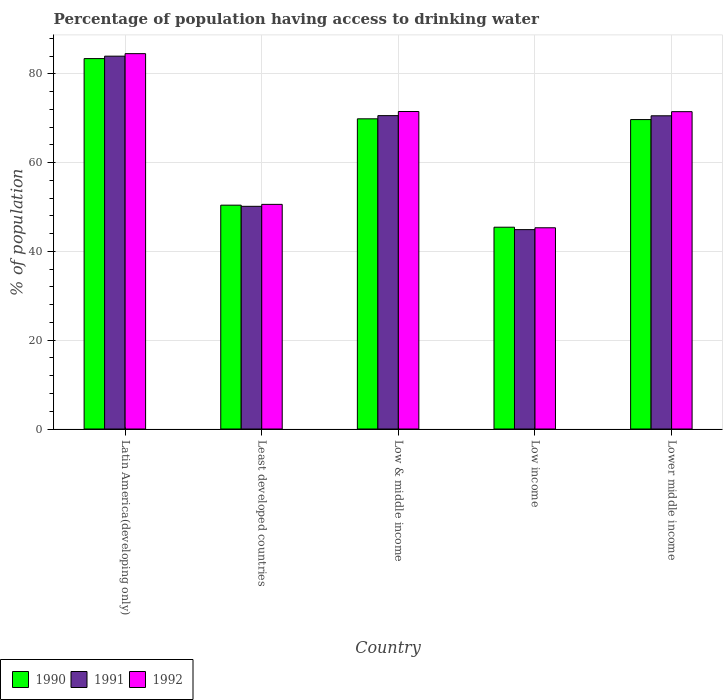Are the number of bars per tick equal to the number of legend labels?
Your response must be concise. Yes. Are the number of bars on each tick of the X-axis equal?
Offer a very short reply. Yes. How many bars are there on the 2nd tick from the right?
Your response must be concise. 3. What is the label of the 2nd group of bars from the left?
Provide a short and direct response. Least developed countries. What is the percentage of population having access to drinking water in 1991 in Latin America(developing only)?
Provide a short and direct response. 83.99. Across all countries, what is the maximum percentage of population having access to drinking water in 1992?
Your answer should be very brief. 84.56. Across all countries, what is the minimum percentage of population having access to drinking water in 1991?
Keep it short and to the point. 44.92. In which country was the percentage of population having access to drinking water in 1992 maximum?
Your answer should be very brief. Latin America(developing only). In which country was the percentage of population having access to drinking water in 1991 minimum?
Provide a short and direct response. Low income. What is the total percentage of population having access to drinking water in 1992 in the graph?
Provide a short and direct response. 323.52. What is the difference between the percentage of population having access to drinking water in 1992 in Latin America(developing only) and that in Low & middle income?
Make the answer very short. 13.04. What is the difference between the percentage of population having access to drinking water in 1991 in Low income and the percentage of population having access to drinking water in 1992 in Low & middle income?
Your response must be concise. -26.61. What is the average percentage of population having access to drinking water in 1991 per country?
Offer a very short reply. 64.05. What is the difference between the percentage of population having access to drinking water of/in 1990 and percentage of population having access to drinking water of/in 1991 in Low income?
Offer a very short reply. 0.54. In how many countries, is the percentage of population having access to drinking water in 1991 greater than 16 %?
Make the answer very short. 5. What is the ratio of the percentage of population having access to drinking water in 1991 in Least developed countries to that in Lower middle income?
Your answer should be very brief. 0.71. What is the difference between the highest and the second highest percentage of population having access to drinking water in 1990?
Offer a terse response. 13.74. What is the difference between the highest and the lowest percentage of population having access to drinking water in 1991?
Provide a short and direct response. 39.08. What does the 3rd bar from the left in Latin America(developing only) represents?
Offer a terse response. 1992. How many bars are there?
Your response must be concise. 15. Are all the bars in the graph horizontal?
Offer a very short reply. No. How many countries are there in the graph?
Make the answer very short. 5. Does the graph contain any zero values?
Provide a short and direct response. No. How many legend labels are there?
Your answer should be compact. 3. How are the legend labels stacked?
Your answer should be very brief. Horizontal. What is the title of the graph?
Provide a short and direct response. Percentage of population having access to drinking water. What is the label or title of the X-axis?
Provide a short and direct response. Country. What is the label or title of the Y-axis?
Your answer should be very brief. % of population. What is the % of population in 1990 in Latin America(developing only)?
Provide a succinct answer. 83.45. What is the % of population in 1991 in Latin America(developing only)?
Offer a very short reply. 83.99. What is the % of population in 1992 in Latin America(developing only)?
Keep it short and to the point. 84.56. What is the % of population in 1990 in Least developed countries?
Your answer should be very brief. 50.43. What is the % of population of 1991 in Least developed countries?
Ensure brevity in your answer.  50.17. What is the % of population of 1992 in Least developed countries?
Ensure brevity in your answer.  50.61. What is the % of population of 1990 in Low & middle income?
Offer a very short reply. 69.88. What is the % of population in 1991 in Low & middle income?
Your answer should be compact. 70.6. What is the % of population in 1992 in Low & middle income?
Keep it short and to the point. 71.53. What is the % of population of 1990 in Low income?
Provide a succinct answer. 45.46. What is the % of population of 1991 in Low income?
Your answer should be compact. 44.92. What is the % of population in 1992 in Low income?
Provide a succinct answer. 45.33. What is the % of population of 1990 in Lower middle income?
Your response must be concise. 69.71. What is the % of population of 1991 in Lower middle income?
Keep it short and to the point. 70.56. What is the % of population in 1992 in Lower middle income?
Make the answer very short. 71.49. Across all countries, what is the maximum % of population in 1990?
Your answer should be very brief. 83.45. Across all countries, what is the maximum % of population of 1991?
Make the answer very short. 83.99. Across all countries, what is the maximum % of population in 1992?
Ensure brevity in your answer.  84.56. Across all countries, what is the minimum % of population of 1990?
Provide a succinct answer. 45.46. Across all countries, what is the minimum % of population in 1991?
Provide a succinct answer. 44.92. Across all countries, what is the minimum % of population of 1992?
Provide a short and direct response. 45.33. What is the total % of population of 1990 in the graph?
Make the answer very short. 318.92. What is the total % of population of 1991 in the graph?
Ensure brevity in your answer.  320.24. What is the total % of population of 1992 in the graph?
Your response must be concise. 323.52. What is the difference between the % of population of 1990 in Latin America(developing only) and that in Least developed countries?
Your response must be concise. 33.02. What is the difference between the % of population of 1991 in Latin America(developing only) and that in Least developed countries?
Provide a short and direct response. 33.83. What is the difference between the % of population of 1992 in Latin America(developing only) and that in Least developed countries?
Your answer should be compact. 33.95. What is the difference between the % of population of 1990 in Latin America(developing only) and that in Low & middle income?
Make the answer very short. 13.57. What is the difference between the % of population in 1991 in Latin America(developing only) and that in Low & middle income?
Your answer should be compact. 13.4. What is the difference between the % of population of 1992 in Latin America(developing only) and that in Low & middle income?
Your answer should be compact. 13.04. What is the difference between the % of population of 1990 in Latin America(developing only) and that in Low income?
Your response must be concise. 37.98. What is the difference between the % of population in 1991 in Latin America(developing only) and that in Low income?
Give a very brief answer. 39.08. What is the difference between the % of population of 1992 in Latin America(developing only) and that in Low income?
Offer a terse response. 39.23. What is the difference between the % of population in 1990 in Latin America(developing only) and that in Lower middle income?
Your response must be concise. 13.74. What is the difference between the % of population in 1991 in Latin America(developing only) and that in Lower middle income?
Your answer should be very brief. 13.43. What is the difference between the % of population of 1992 in Latin America(developing only) and that in Lower middle income?
Offer a very short reply. 13.07. What is the difference between the % of population of 1990 in Least developed countries and that in Low & middle income?
Ensure brevity in your answer.  -19.45. What is the difference between the % of population of 1991 in Least developed countries and that in Low & middle income?
Keep it short and to the point. -20.43. What is the difference between the % of population of 1992 in Least developed countries and that in Low & middle income?
Keep it short and to the point. -20.92. What is the difference between the % of population of 1990 in Least developed countries and that in Low income?
Provide a succinct answer. 4.97. What is the difference between the % of population in 1991 in Least developed countries and that in Low income?
Your answer should be compact. 5.25. What is the difference between the % of population of 1992 in Least developed countries and that in Low income?
Keep it short and to the point. 5.27. What is the difference between the % of population of 1990 in Least developed countries and that in Lower middle income?
Offer a very short reply. -19.28. What is the difference between the % of population of 1991 in Least developed countries and that in Lower middle income?
Provide a succinct answer. -20.39. What is the difference between the % of population of 1992 in Least developed countries and that in Lower middle income?
Your answer should be very brief. -20.88. What is the difference between the % of population of 1990 in Low & middle income and that in Low income?
Ensure brevity in your answer.  24.42. What is the difference between the % of population in 1991 in Low & middle income and that in Low income?
Provide a succinct answer. 25.68. What is the difference between the % of population in 1992 in Low & middle income and that in Low income?
Offer a very short reply. 26.19. What is the difference between the % of population in 1990 in Low & middle income and that in Lower middle income?
Provide a succinct answer. 0.17. What is the difference between the % of population of 1991 in Low & middle income and that in Lower middle income?
Ensure brevity in your answer.  0.03. What is the difference between the % of population of 1992 in Low & middle income and that in Lower middle income?
Offer a terse response. 0.03. What is the difference between the % of population of 1990 in Low income and that in Lower middle income?
Your answer should be very brief. -24.25. What is the difference between the % of population in 1991 in Low income and that in Lower middle income?
Offer a terse response. -25.64. What is the difference between the % of population of 1992 in Low income and that in Lower middle income?
Offer a very short reply. -26.16. What is the difference between the % of population of 1990 in Latin America(developing only) and the % of population of 1991 in Least developed countries?
Give a very brief answer. 33.28. What is the difference between the % of population in 1990 in Latin America(developing only) and the % of population in 1992 in Least developed countries?
Keep it short and to the point. 32.84. What is the difference between the % of population in 1991 in Latin America(developing only) and the % of population in 1992 in Least developed countries?
Your answer should be compact. 33.39. What is the difference between the % of population of 1990 in Latin America(developing only) and the % of population of 1991 in Low & middle income?
Ensure brevity in your answer.  12.85. What is the difference between the % of population of 1990 in Latin America(developing only) and the % of population of 1992 in Low & middle income?
Keep it short and to the point. 11.92. What is the difference between the % of population of 1991 in Latin America(developing only) and the % of population of 1992 in Low & middle income?
Provide a succinct answer. 12.47. What is the difference between the % of population in 1990 in Latin America(developing only) and the % of population in 1991 in Low income?
Keep it short and to the point. 38.53. What is the difference between the % of population of 1990 in Latin America(developing only) and the % of population of 1992 in Low income?
Keep it short and to the point. 38.11. What is the difference between the % of population in 1991 in Latin America(developing only) and the % of population in 1992 in Low income?
Your answer should be compact. 38.66. What is the difference between the % of population in 1990 in Latin America(developing only) and the % of population in 1991 in Lower middle income?
Provide a succinct answer. 12.88. What is the difference between the % of population of 1990 in Latin America(developing only) and the % of population of 1992 in Lower middle income?
Provide a short and direct response. 11.95. What is the difference between the % of population of 1991 in Latin America(developing only) and the % of population of 1992 in Lower middle income?
Provide a succinct answer. 12.5. What is the difference between the % of population of 1990 in Least developed countries and the % of population of 1991 in Low & middle income?
Offer a terse response. -20.17. What is the difference between the % of population of 1990 in Least developed countries and the % of population of 1992 in Low & middle income?
Your answer should be compact. -21.1. What is the difference between the % of population in 1991 in Least developed countries and the % of population in 1992 in Low & middle income?
Provide a succinct answer. -21.36. What is the difference between the % of population of 1990 in Least developed countries and the % of population of 1991 in Low income?
Provide a short and direct response. 5.51. What is the difference between the % of population of 1990 in Least developed countries and the % of population of 1992 in Low income?
Provide a succinct answer. 5.09. What is the difference between the % of population in 1991 in Least developed countries and the % of population in 1992 in Low income?
Your answer should be compact. 4.83. What is the difference between the % of population of 1990 in Least developed countries and the % of population of 1991 in Lower middle income?
Make the answer very short. -20.13. What is the difference between the % of population in 1990 in Least developed countries and the % of population in 1992 in Lower middle income?
Provide a short and direct response. -21.06. What is the difference between the % of population of 1991 in Least developed countries and the % of population of 1992 in Lower middle income?
Your answer should be compact. -21.32. What is the difference between the % of population of 1990 in Low & middle income and the % of population of 1991 in Low income?
Make the answer very short. 24.96. What is the difference between the % of population in 1990 in Low & middle income and the % of population in 1992 in Low income?
Offer a terse response. 24.54. What is the difference between the % of population in 1991 in Low & middle income and the % of population in 1992 in Low income?
Offer a very short reply. 25.26. What is the difference between the % of population in 1990 in Low & middle income and the % of population in 1991 in Lower middle income?
Offer a terse response. -0.69. What is the difference between the % of population of 1990 in Low & middle income and the % of population of 1992 in Lower middle income?
Give a very brief answer. -1.61. What is the difference between the % of population in 1991 in Low & middle income and the % of population in 1992 in Lower middle income?
Your answer should be very brief. -0.9. What is the difference between the % of population in 1990 in Low income and the % of population in 1991 in Lower middle income?
Provide a short and direct response. -25.1. What is the difference between the % of population in 1990 in Low income and the % of population in 1992 in Lower middle income?
Ensure brevity in your answer.  -26.03. What is the difference between the % of population in 1991 in Low income and the % of population in 1992 in Lower middle income?
Provide a short and direct response. -26.57. What is the average % of population of 1990 per country?
Ensure brevity in your answer.  63.78. What is the average % of population in 1991 per country?
Provide a short and direct response. 64.05. What is the average % of population of 1992 per country?
Your answer should be very brief. 64.7. What is the difference between the % of population in 1990 and % of population in 1991 in Latin America(developing only)?
Your answer should be very brief. -0.55. What is the difference between the % of population of 1990 and % of population of 1992 in Latin America(developing only)?
Keep it short and to the point. -1.12. What is the difference between the % of population in 1991 and % of population in 1992 in Latin America(developing only)?
Your response must be concise. -0.57. What is the difference between the % of population in 1990 and % of population in 1991 in Least developed countries?
Offer a very short reply. 0.26. What is the difference between the % of population in 1990 and % of population in 1992 in Least developed countries?
Provide a short and direct response. -0.18. What is the difference between the % of population of 1991 and % of population of 1992 in Least developed countries?
Your answer should be very brief. -0.44. What is the difference between the % of population in 1990 and % of population in 1991 in Low & middle income?
Provide a succinct answer. -0.72. What is the difference between the % of population in 1990 and % of population in 1992 in Low & middle income?
Offer a very short reply. -1.65. What is the difference between the % of population in 1991 and % of population in 1992 in Low & middle income?
Provide a short and direct response. -0.93. What is the difference between the % of population of 1990 and % of population of 1991 in Low income?
Give a very brief answer. 0.54. What is the difference between the % of population in 1990 and % of population in 1992 in Low income?
Offer a very short reply. 0.13. What is the difference between the % of population in 1991 and % of population in 1992 in Low income?
Make the answer very short. -0.42. What is the difference between the % of population of 1990 and % of population of 1991 in Lower middle income?
Your answer should be compact. -0.85. What is the difference between the % of population of 1990 and % of population of 1992 in Lower middle income?
Give a very brief answer. -1.78. What is the difference between the % of population in 1991 and % of population in 1992 in Lower middle income?
Ensure brevity in your answer.  -0.93. What is the ratio of the % of population in 1990 in Latin America(developing only) to that in Least developed countries?
Offer a very short reply. 1.65. What is the ratio of the % of population in 1991 in Latin America(developing only) to that in Least developed countries?
Ensure brevity in your answer.  1.67. What is the ratio of the % of population of 1992 in Latin America(developing only) to that in Least developed countries?
Provide a short and direct response. 1.67. What is the ratio of the % of population in 1990 in Latin America(developing only) to that in Low & middle income?
Give a very brief answer. 1.19. What is the ratio of the % of population in 1991 in Latin America(developing only) to that in Low & middle income?
Keep it short and to the point. 1.19. What is the ratio of the % of population of 1992 in Latin America(developing only) to that in Low & middle income?
Offer a very short reply. 1.18. What is the ratio of the % of population of 1990 in Latin America(developing only) to that in Low income?
Your answer should be very brief. 1.84. What is the ratio of the % of population in 1991 in Latin America(developing only) to that in Low income?
Offer a very short reply. 1.87. What is the ratio of the % of population in 1992 in Latin America(developing only) to that in Low income?
Ensure brevity in your answer.  1.87. What is the ratio of the % of population of 1990 in Latin America(developing only) to that in Lower middle income?
Provide a short and direct response. 1.2. What is the ratio of the % of population of 1991 in Latin America(developing only) to that in Lower middle income?
Offer a very short reply. 1.19. What is the ratio of the % of population of 1992 in Latin America(developing only) to that in Lower middle income?
Your response must be concise. 1.18. What is the ratio of the % of population of 1990 in Least developed countries to that in Low & middle income?
Provide a succinct answer. 0.72. What is the ratio of the % of population in 1991 in Least developed countries to that in Low & middle income?
Ensure brevity in your answer.  0.71. What is the ratio of the % of population in 1992 in Least developed countries to that in Low & middle income?
Your response must be concise. 0.71. What is the ratio of the % of population of 1990 in Least developed countries to that in Low income?
Your response must be concise. 1.11. What is the ratio of the % of population in 1991 in Least developed countries to that in Low income?
Offer a very short reply. 1.12. What is the ratio of the % of population of 1992 in Least developed countries to that in Low income?
Ensure brevity in your answer.  1.12. What is the ratio of the % of population in 1990 in Least developed countries to that in Lower middle income?
Provide a short and direct response. 0.72. What is the ratio of the % of population in 1991 in Least developed countries to that in Lower middle income?
Make the answer very short. 0.71. What is the ratio of the % of population of 1992 in Least developed countries to that in Lower middle income?
Keep it short and to the point. 0.71. What is the ratio of the % of population in 1990 in Low & middle income to that in Low income?
Offer a very short reply. 1.54. What is the ratio of the % of population of 1991 in Low & middle income to that in Low income?
Ensure brevity in your answer.  1.57. What is the ratio of the % of population in 1992 in Low & middle income to that in Low income?
Make the answer very short. 1.58. What is the ratio of the % of population in 1990 in Low income to that in Lower middle income?
Give a very brief answer. 0.65. What is the ratio of the % of population of 1991 in Low income to that in Lower middle income?
Keep it short and to the point. 0.64. What is the ratio of the % of population in 1992 in Low income to that in Lower middle income?
Provide a succinct answer. 0.63. What is the difference between the highest and the second highest % of population in 1990?
Your answer should be compact. 13.57. What is the difference between the highest and the second highest % of population of 1991?
Offer a very short reply. 13.4. What is the difference between the highest and the second highest % of population of 1992?
Make the answer very short. 13.04. What is the difference between the highest and the lowest % of population in 1990?
Provide a succinct answer. 37.98. What is the difference between the highest and the lowest % of population in 1991?
Give a very brief answer. 39.08. What is the difference between the highest and the lowest % of population in 1992?
Offer a terse response. 39.23. 